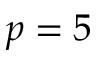<formula> <loc_0><loc_0><loc_500><loc_500>p = 5</formula> 